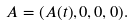<formula> <loc_0><loc_0><loc_500><loc_500>A = ( A ( t ) , 0 , 0 , 0 ) .</formula> 